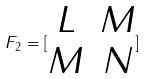Convert formula to latex. <formula><loc_0><loc_0><loc_500><loc_500>F _ { 2 } = [ \begin{matrix} L & M \\ M & N \end{matrix} ]</formula> 